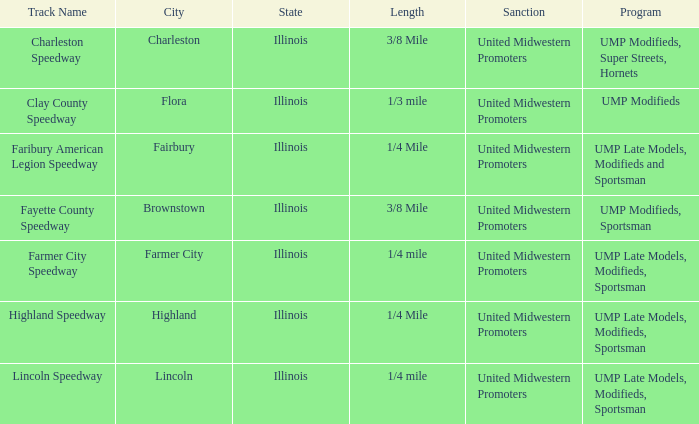Who sanctioned the event in lincoln, illinois? United Midwestern Promoters. 